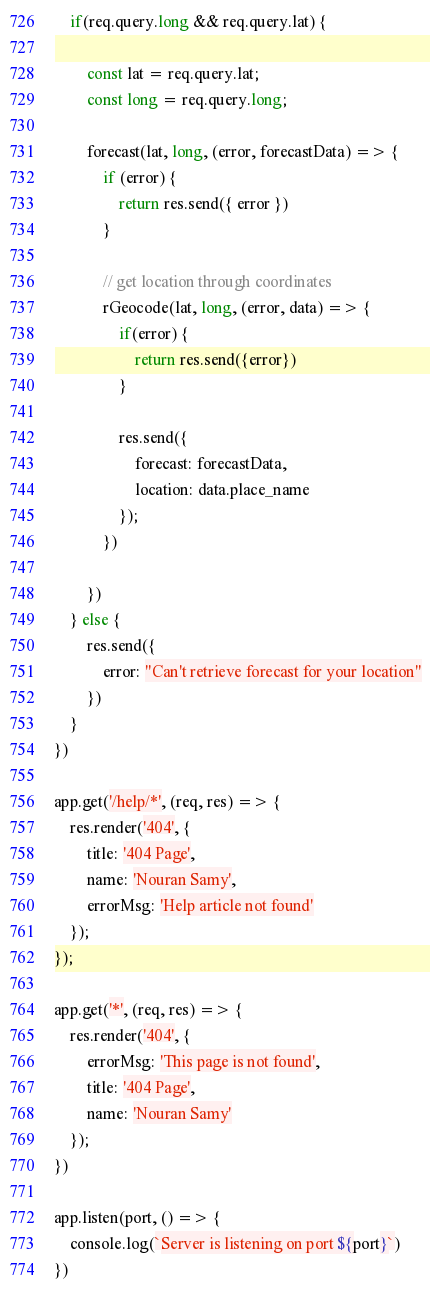Convert code to text. <code><loc_0><loc_0><loc_500><loc_500><_JavaScript_>
    if(req.query.long && req.query.lat) {

        const lat = req.query.lat;
        const long = req.query.long;

        forecast(lat, long, (error, forecastData) => {
            if (error) {
                return res.send({ error })
            }

            // get location through coordinates
            rGeocode(lat, long, (error, data) => {
                if(error) {
                    return res.send({error})
                }

                res.send({
                    forecast: forecastData,
                    location: data.place_name
                });
            })
    
        })
    } else {
        res.send({
            error: "Can't retrieve forecast for your location"
        })
    }
})

app.get('/help/*', (req, res) => {
    res.render('404', {
        title: '404 Page',
        name: 'Nouran Samy',
        errorMsg: 'Help article not found'
    });
});

app.get('*', (req, res) => {
    res.render('404', {
        errorMsg: 'This page is not found',
        title: '404 Page',
        name: 'Nouran Samy'
    });
})

app.listen(port, () => {
    console.log(`Server is listening on port ${port}`)
})</code> 